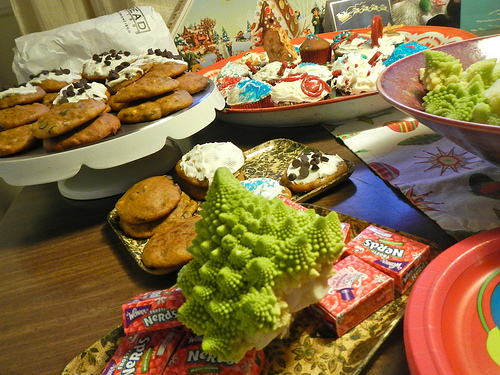<image>
Is the placemat on the table? Yes. Looking at the image, I can see the placemat is positioned on top of the table, with the table providing support. 